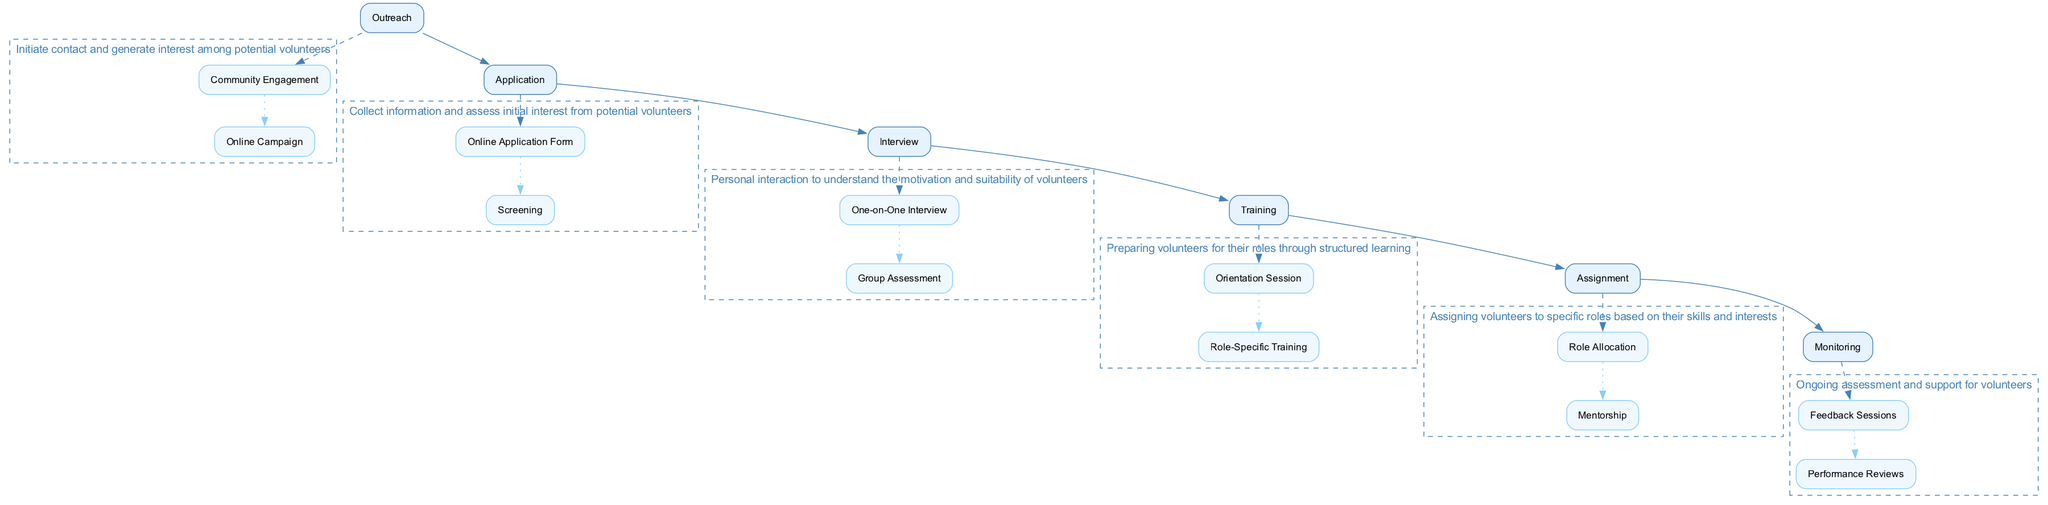What is the first stage of the volunteer process? The first stage listed in the diagram is "Outreach". This is determined by looking at the topmost element in the main nodes of the block diagram.
Answer: Outreach How many main stages are there in the recruitment process? There are six main stages identified in the diagram: Outreach, Application, Interview, Training, Assignment, and Monitoring. Adding these stages together gives the total count of six main stages.
Answer: 6 What is the role of the "Screening" sub-element? "Screening" is part of the "Application" stage and refers to initial background checks and review of applications. This can be directly derived from looking at the sub-elements listed under the "Application" stage.
Answer: Initial background checks Which main stage connects to "Orientation Session"? "Orientation Session" is connected to the "Training" main stage, as it is one of the sub-elements within it. The connection is established by identifying the sub-elements related to the main stage of "Training".
Answer: Training How many sub-elements are under the "Monitoring" stage? There are two sub-elements under the "Monitoring" stage: "Feedback Sessions" and "Performance Reviews". Counting these gives the total of two sub-elements associated with "Monitoring".
Answer: 2 What is the objective of the "Group Assessment"? The objective of the "Group Assessment" is to assess teamwork and communication through group activities. This description is found by examining the relevant sub-element under the "Interview" stage.
Answer: Teamwork and communication assessment Which two sub-elements are related to "Assignment"? The two sub-elements related to "Assignment" are "Role Allocation" and "Mentorship". This can be determined by looking at the sub-elements listed under the "Assignment" main stage.
Answer: Role Allocation and Mentorship What is an example of an outreach strategy mentioned? An example of an outreach strategy is "Online Campaign". This is derived from the "Outreach" stage, where its specific sub-elements are described, including the online strategy.
Answer: Online Campaign What connects the "Interview" to "Training"? The connection between "Interview" and "Training" is through the sequential flow of the main stages in the process, as "Training" follows "Interview" in the order presented in the block diagram.
Answer: Sequential flow 